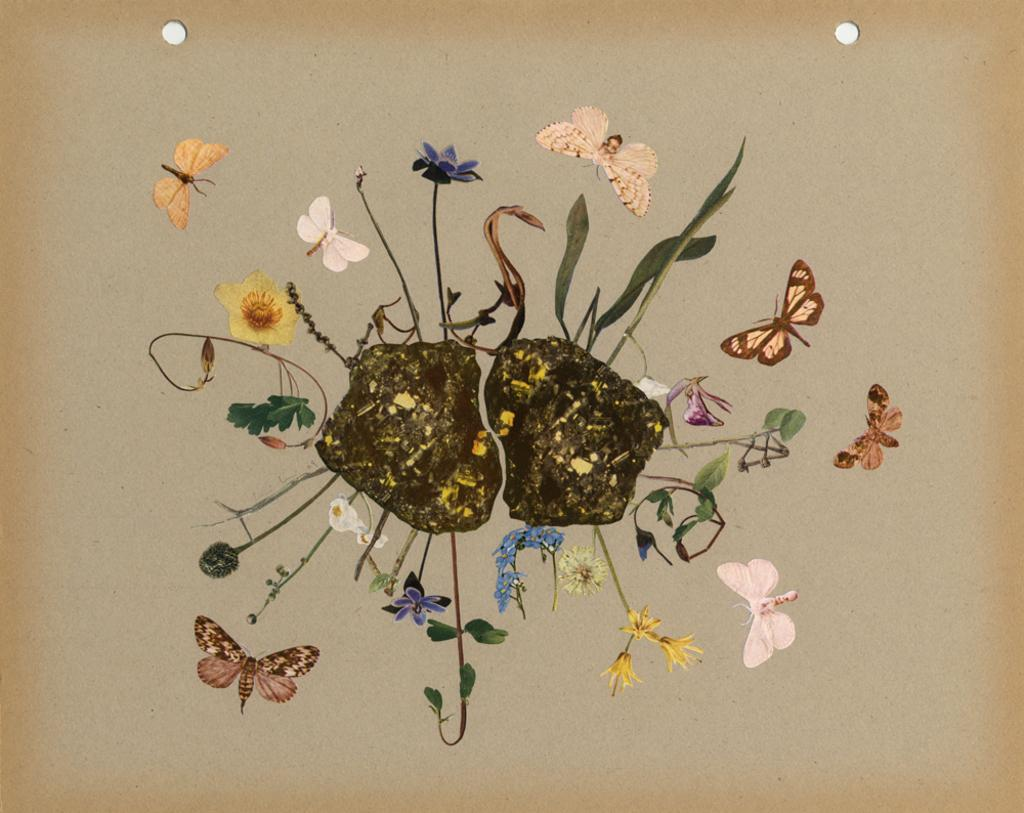What is the main subject of the artwork in the image? The painting on paper in the image contains butterflies, flowers, and leaves. What type of artwork is depicted in the image? The artwork is a painting on paper. What other elements are present in the painting besides butterflies? The painting also contains flowers and leaves. What year was the painting created in the image? The year the painting was created is not mentioned in the image, so it cannot be determined. How many clovers are present in the painting in the image? There are no clovers present in the painting; it contains butterflies, flowers, and leaves. 